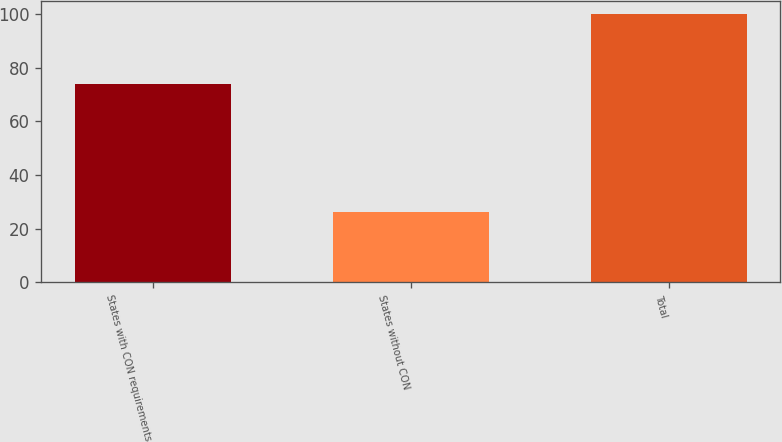<chart> <loc_0><loc_0><loc_500><loc_500><bar_chart><fcel>States with CON requirements<fcel>States without CON<fcel>Total<nl><fcel>74<fcel>26<fcel>100<nl></chart> 